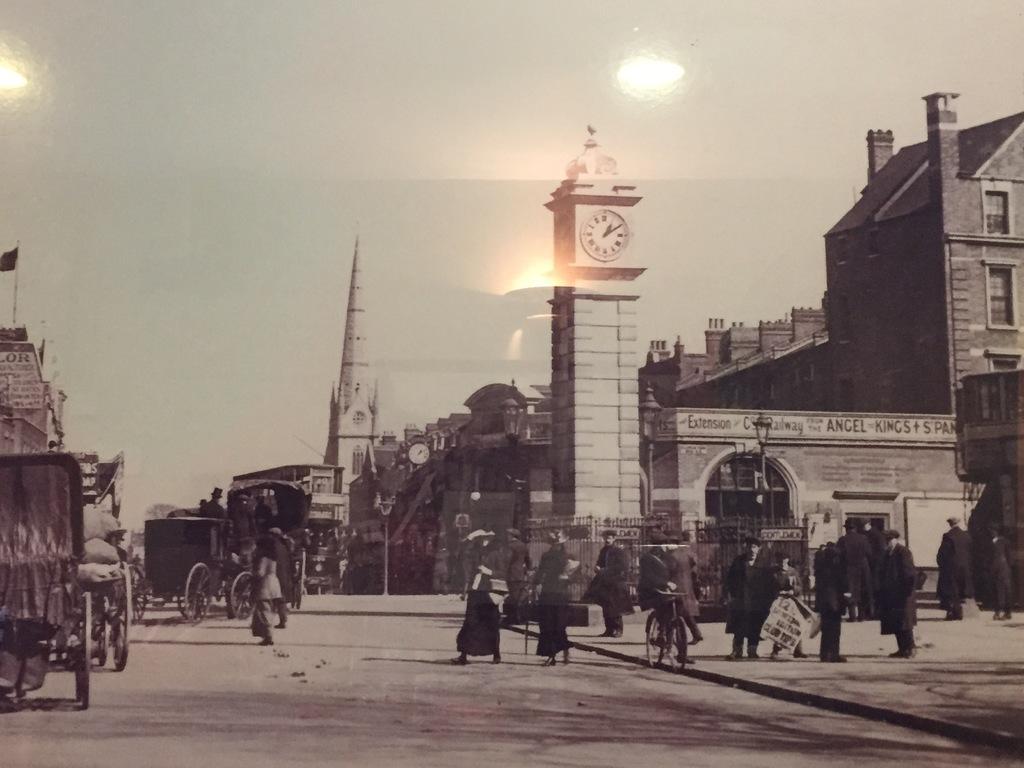Can you describe this image briefly? In this picture there are group of people on the road and there are buildings and poles and there are vehicles on the road and there is a flag on the building and there is a clock on the building. At the back there is a railing. At the top there is sky and there are reflections of lights. At the bottom there is a road. 